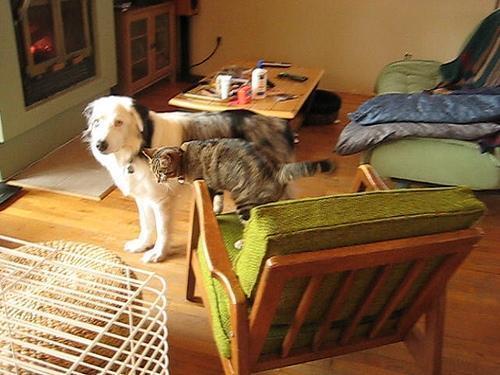How many cows are photographed?
Give a very brief answer. 0. 